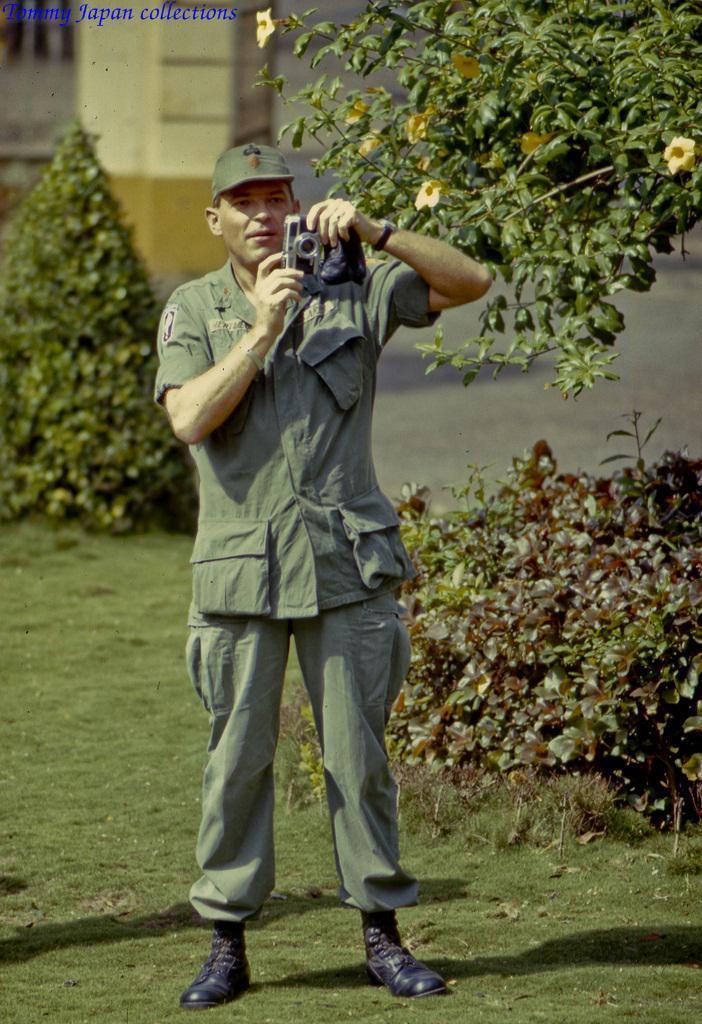Describe this image in one or two sentences. In this picture there is a person standing and holding the camera. At the back there is a building and there are trees. In the top right there are flowers on the tree. In the top left there is a text. At the bottom there is grass. 